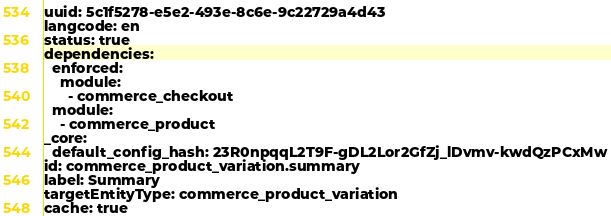Convert code to text. <code><loc_0><loc_0><loc_500><loc_500><_YAML_>uuid: 5c1f5278-e5e2-493e-8c6e-9c22729a4d43
langcode: en
status: true
dependencies:
  enforced:
    module:
      - commerce_checkout
  module:
    - commerce_product
_core:
  default_config_hash: 23R0npqqL2T9F-gDL2Lor2GfZj_lDvmv-kwdQzPCxMw
id: commerce_product_variation.summary
label: Summary
targetEntityType: commerce_product_variation
cache: true
</code> 